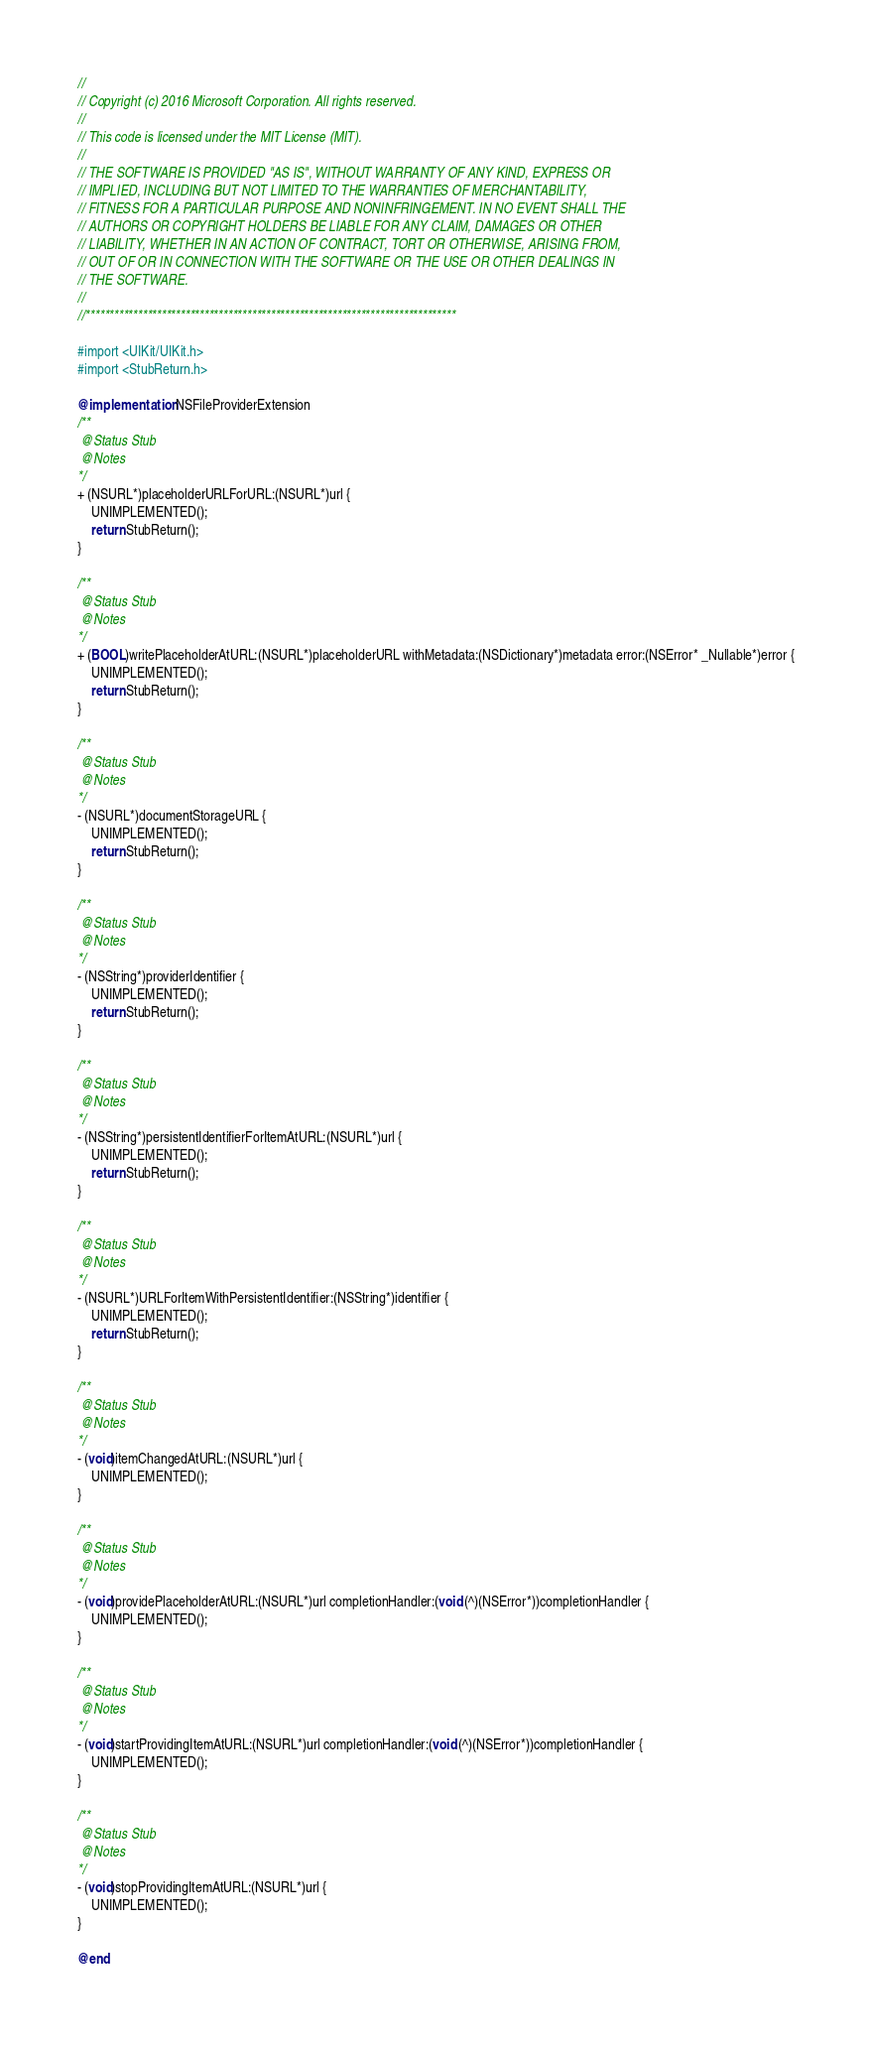<code> <loc_0><loc_0><loc_500><loc_500><_ObjectiveC_>//
// Copyright (c) 2016 Microsoft Corporation. All rights reserved.
//
// This code is licensed under the MIT License (MIT).
//
// THE SOFTWARE IS PROVIDED "AS IS", WITHOUT WARRANTY OF ANY KIND, EXPRESS OR
// IMPLIED, INCLUDING BUT NOT LIMITED TO THE WARRANTIES OF MERCHANTABILITY,
// FITNESS FOR A PARTICULAR PURPOSE AND NONINFRINGEMENT. IN NO EVENT SHALL THE
// AUTHORS OR COPYRIGHT HOLDERS BE LIABLE FOR ANY CLAIM, DAMAGES OR OTHER
// LIABILITY, WHETHER IN AN ACTION OF CONTRACT, TORT OR OTHERWISE, ARISING FROM,
// OUT OF OR IN CONNECTION WITH THE SOFTWARE OR THE USE OR OTHER DEALINGS IN
// THE SOFTWARE.
//
//******************************************************************************

#import <UIKit/UIKit.h>
#import <StubReturn.h>

@implementation NSFileProviderExtension
/**
 @Status Stub
 @Notes
*/
+ (NSURL*)placeholderURLForURL:(NSURL*)url {
    UNIMPLEMENTED();
    return StubReturn();
}

/**
 @Status Stub
 @Notes
*/
+ (BOOL)writePlaceholderAtURL:(NSURL*)placeholderURL withMetadata:(NSDictionary*)metadata error:(NSError* _Nullable*)error {
    UNIMPLEMENTED();
    return StubReturn();
}

/**
 @Status Stub
 @Notes
*/
- (NSURL*)documentStorageURL {
    UNIMPLEMENTED();
    return StubReturn();
}

/**
 @Status Stub
 @Notes
*/
- (NSString*)providerIdentifier {
    UNIMPLEMENTED();
    return StubReturn();
}

/**
 @Status Stub
 @Notes
*/
- (NSString*)persistentIdentifierForItemAtURL:(NSURL*)url {
    UNIMPLEMENTED();
    return StubReturn();
}

/**
 @Status Stub
 @Notes
*/
- (NSURL*)URLForItemWithPersistentIdentifier:(NSString*)identifier {
    UNIMPLEMENTED();
    return StubReturn();
}

/**
 @Status Stub
 @Notes
*/
- (void)itemChangedAtURL:(NSURL*)url {
    UNIMPLEMENTED();
}

/**
 @Status Stub
 @Notes
*/
- (void)providePlaceholderAtURL:(NSURL*)url completionHandler:(void (^)(NSError*))completionHandler {
    UNIMPLEMENTED();
}

/**
 @Status Stub
 @Notes
*/
- (void)startProvidingItemAtURL:(NSURL*)url completionHandler:(void (^)(NSError*))completionHandler {
    UNIMPLEMENTED();
}

/**
 @Status Stub
 @Notes
*/
- (void)stopProvidingItemAtURL:(NSURL*)url {
    UNIMPLEMENTED();
}

@end
</code> 